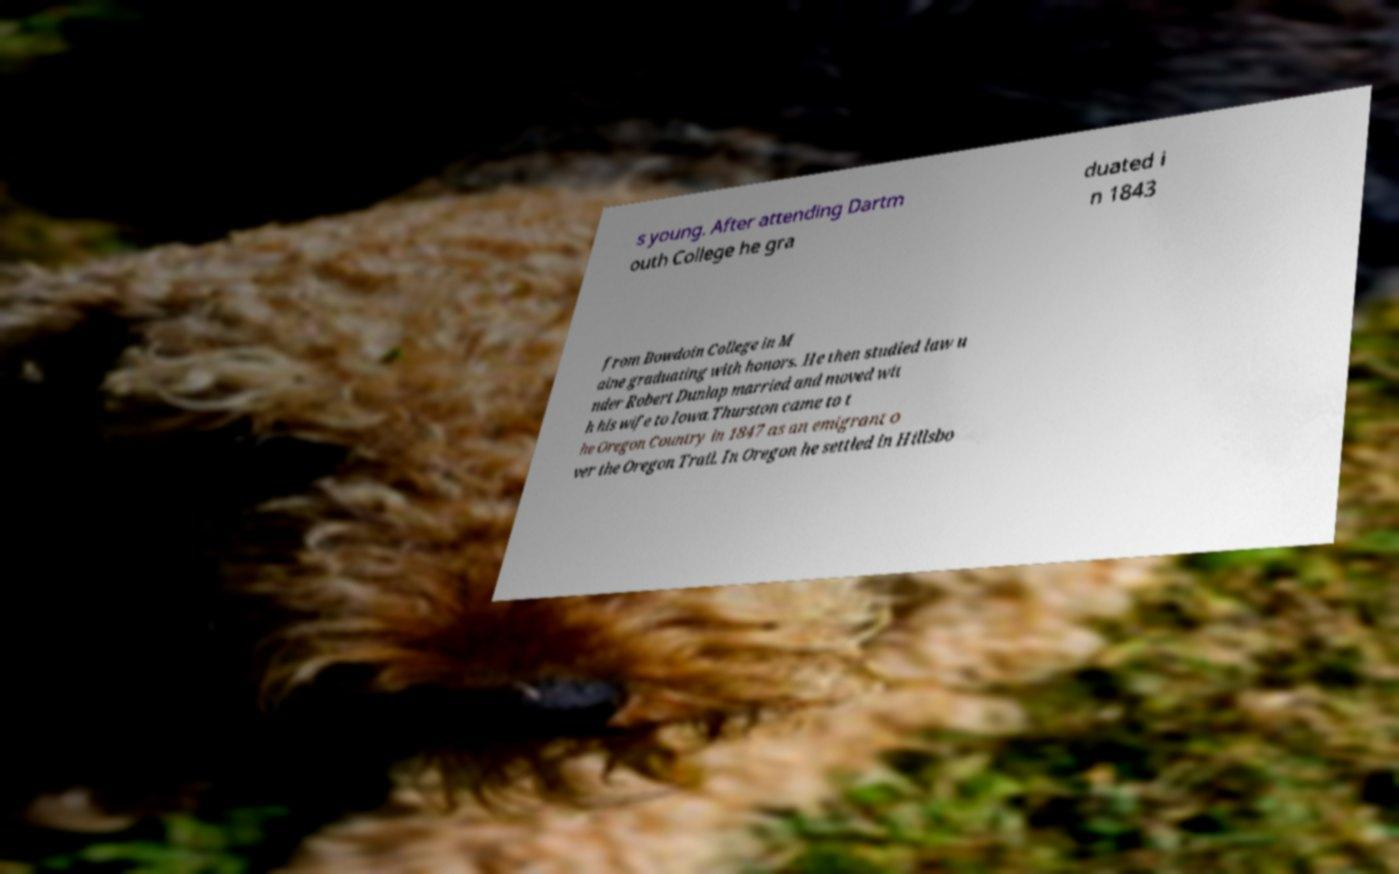What messages or text are displayed in this image? I need them in a readable, typed format. s young. After attending Dartm outh College he gra duated i n 1843 from Bowdoin College in M aine graduating with honors. He then studied law u nder Robert Dunlap married and moved wit h his wife to Iowa.Thurston came to t he Oregon Country in 1847 as an emigrant o ver the Oregon Trail. In Oregon he settled in Hillsbo 